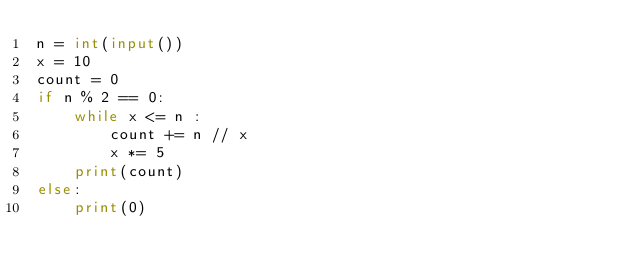<code> <loc_0><loc_0><loc_500><loc_500><_Python_>n = int(input())
x = 10
count = 0
if n % 2 == 0:
    while x <= n :
        count += n // x
        x *= 5
    print(count)
else:
    print(0)
</code> 